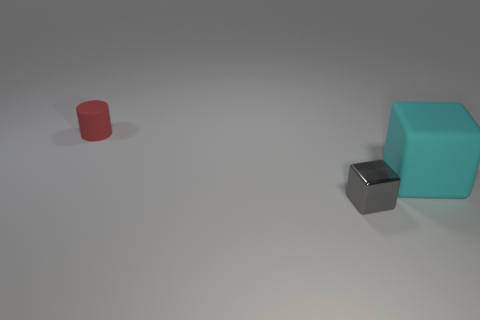Are there more cyan blocks left of the large object than small gray objects?
Give a very brief answer. No. There is a thing that is made of the same material as the cyan block; what size is it?
Make the answer very short. Small. Are there any tiny things that have the same color as the tiny metal cube?
Your answer should be very brief. No. How many things are tiny rubber things or small objects that are in front of the tiny red cylinder?
Your response must be concise. 2. Are there more big cyan things than big blue matte cylinders?
Offer a very short reply. Yes. Are there any small gray things made of the same material as the small gray block?
Your answer should be very brief. No. The object that is behind the small shiny block and left of the cyan block has what shape?
Provide a short and direct response. Cylinder. How many other objects are the same shape as the big cyan rubber object?
Give a very brief answer. 1. The rubber cube is what size?
Offer a very short reply. Large. How many things are small gray shiny blocks or small cylinders?
Your response must be concise. 2. 